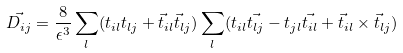<formula> <loc_0><loc_0><loc_500><loc_500>\vec { D _ { i j } } = \frac { 8 } { \epsilon ^ { 3 } } \sum _ { l } ( t _ { i l } t _ { l j } + \vec { t } _ { i l } \vec { t } _ { l j } ) \sum _ { l } ( t _ { i l } \vec { t _ { l j } } - t _ { j l } \vec { t _ { i l } } + \vec { t } _ { i l } \times \vec { t } _ { l j } )</formula> 